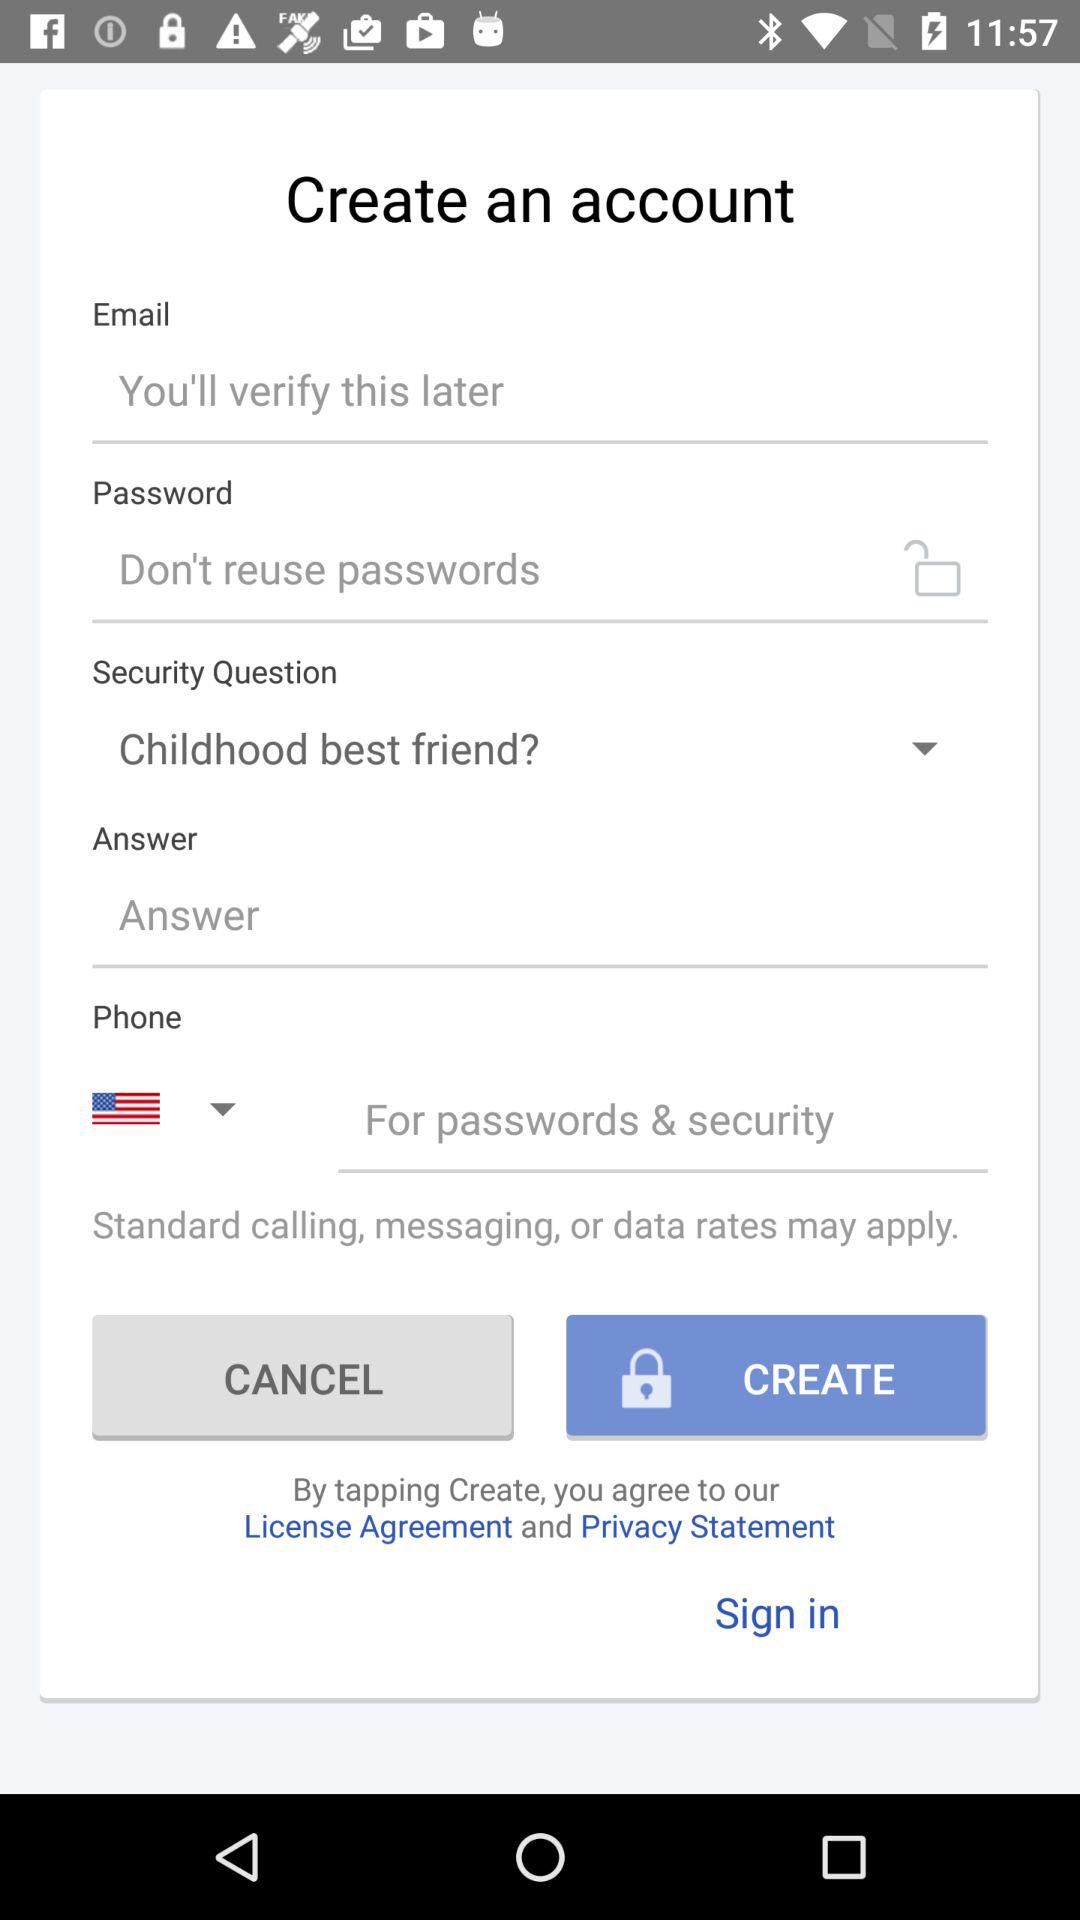What is the selected security question? The selected security question is "Childhood best friend?". 